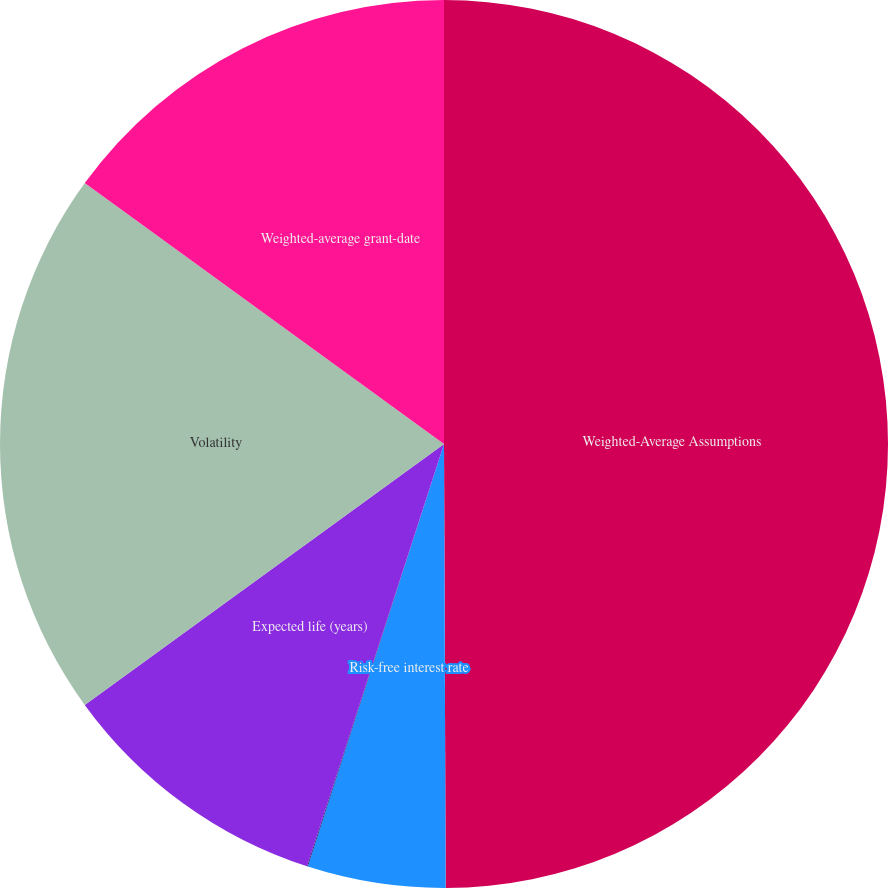<chart> <loc_0><loc_0><loc_500><loc_500><pie_chart><fcel>Weighted-Average Assumptions<fcel>Risk-free interest rate<fcel>Dividend yield<fcel>Expected life (years)<fcel>Volatility<fcel>Weighted-average grant-date<nl><fcel>49.93%<fcel>5.02%<fcel>0.03%<fcel>10.01%<fcel>19.99%<fcel>15.0%<nl></chart> 